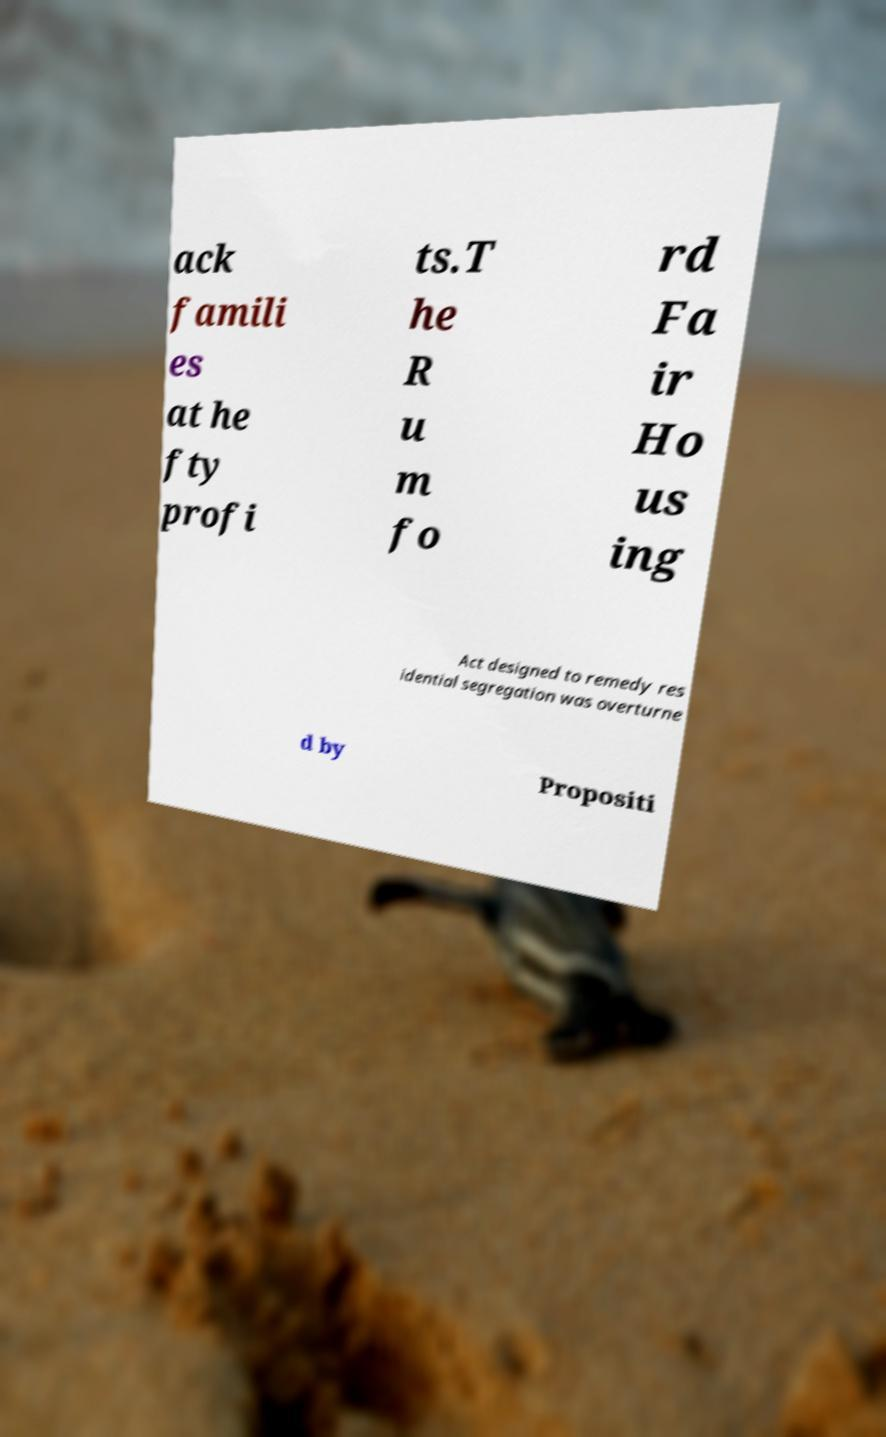Can you read and provide the text displayed in the image?This photo seems to have some interesting text. Can you extract and type it out for me? ack famili es at he fty profi ts.T he R u m fo rd Fa ir Ho us ing Act designed to remedy res idential segregation was overturne d by Propositi 